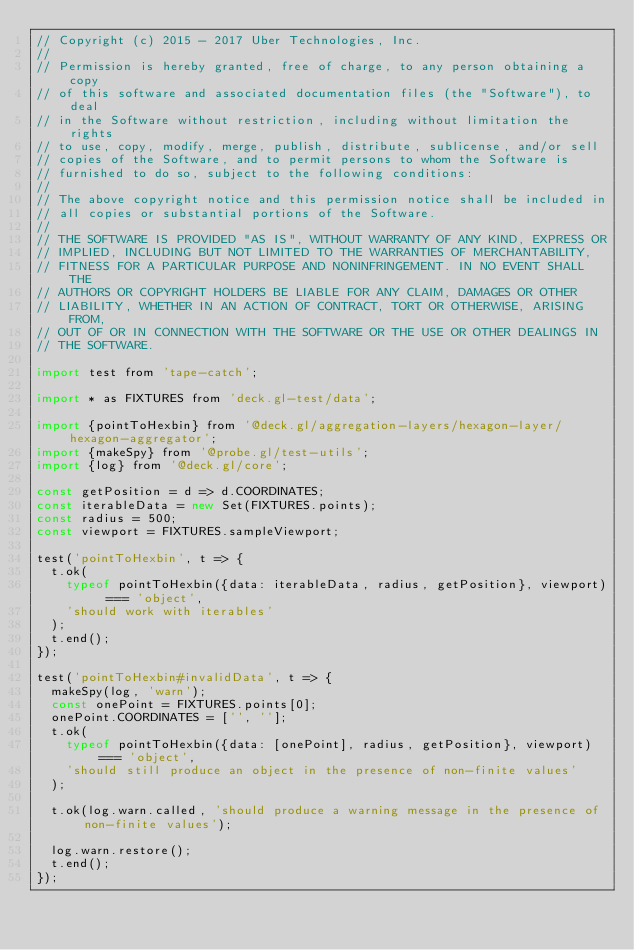Convert code to text. <code><loc_0><loc_0><loc_500><loc_500><_JavaScript_>// Copyright (c) 2015 - 2017 Uber Technologies, Inc.
//
// Permission is hereby granted, free of charge, to any person obtaining a copy
// of this software and associated documentation files (the "Software"), to deal
// in the Software without restriction, including without limitation the rights
// to use, copy, modify, merge, publish, distribute, sublicense, and/or sell
// copies of the Software, and to permit persons to whom the Software is
// furnished to do so, subject to the following conditions:
//
// The above copyright notice and this permission notice shall be included in
// all copies or substantial portions of the Software.
//
// THE SOFTWARE IS PROVIDED "AS IS", WITHOUT WARRANTY OF ANY KIND, EXPRESS OR
// IMPLIED, INCLUDING BUT NOT LIMITED TO THE WARRANTIES OF MERCHANTABILITY,
// FITNESS FOR A PARTICULAR PURPOSE AND NONINFRINGEMENT. IN NO EVENT SHALL THE
// AUTHORS OR COPYRIGHT HOLDERS BE LIABLE FOR ANY CLAIM, DAMAGES OR OTHER
// LIABILITY, WHETHER IN AN ACTION OF CONTRACT, TORT OR OTHERWISE, ARISING FROM,
// OUT OF OR IN CONNECTION WITH THE SOFTWARE OR THE USE OR OTHER DEALINGS IN
// THE SOFTWARE.

import test from 'tape-catch';

import * as FIXTURES from 'deck.gl-test/data';

import {pointToHexbin} from '@deck.gl/aggregation-layers/hexagon-layer/hexagon-aggregator';
import {makeSpy} from '@probe.gl/test-utils';
import {log} from '@deck.gl/core';

const getPosition = d => d.COORDINATES;
const iterableData = new Set(FIXTURES.points);
const radius = 500;
const viewport = FIXTURES.sampleViewport;

test('pointToHexbin', t => {
  t.ok(
    typeof pointToHexbin({data: iterableData, radius, getPosition}, viewport) === 'object',
    'should work with iterables'
  );
  t.end();
});

test('pointToHexbin#invalidData', t => {
  makeSpy(log, 'warn');
  const onePoint = FIXTURES.points[0];
  onePoint.COORDINATES = ['', ''];
  t.ok(
    typeof pointToHexbin({data: [onePoint], radius, getPosition}, viewport) === 'object',
    'should still produce an object in the presence of non-finite values'
  );

  t.ok(log.warn.called, 'should produce a warning message in the presence of non-finite values');

  log.warn.restore();
  t.end();
});
</code> 